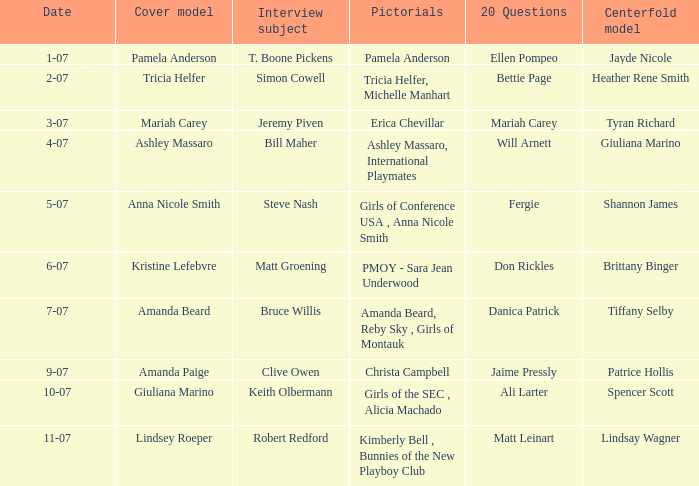Who answered the 20 questions on 10-07? Ali Larter. 